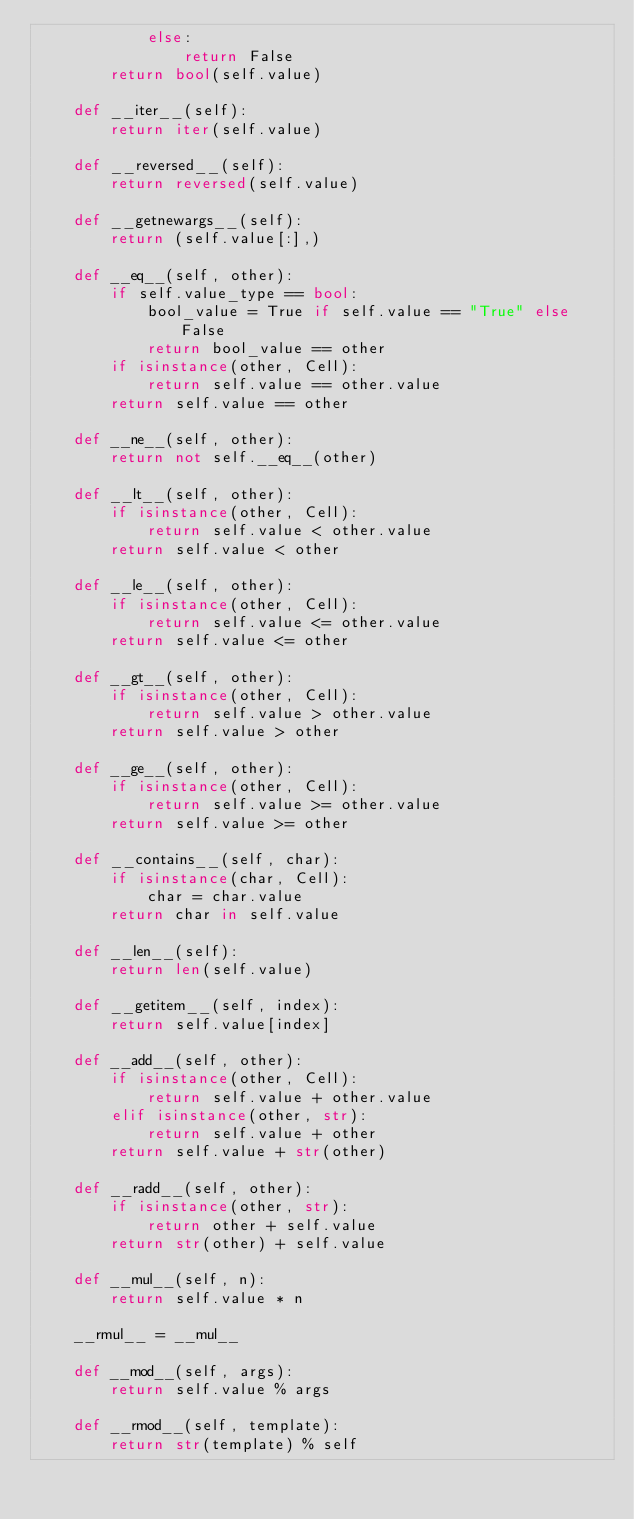<code> <loc_0><loc_0><loc_500><loc_500><_Python_>            else:
                return False
        return bool(self.value)

    def __iter__(self):
        return iter(self.value)

    def __reversed__(self):
        return reversed(self.value)

    def __getnewargs__(self):
        return (self.value[:],)

    def __eq__(self, other):
        if self.value_type == bool:
            bool_value = True if self.value == "True" else False
            return bool_value == other
        if isinstance(other, Cell):
            return self.value == other.value
        return self.value == other

    def __ne__(self, other):
        return not self.__eq__(other)

    def __lt__(self, other):
        if isinstance(other, Cell):
            return self.value < other.value
        return self.value < other

    def __le__(self, other):
        if isinstance(other, Cell):
            return self.value <= other.value
        return self.value <= other

    def __gt__(self, other):
        if isinstance(other, Cell):
            return self.value > other.value
        return self.value > other

    def __ge__(self, other):
        if isinstance(other, Cell):
            return self.value >= other.value
        return self.value >= other

    def __contains__(self, char):
        if isinstance(char, Cell):
            char = char.value
        return char in self.value

    def __len__(self):
        return len(self.value)

    def __getitem__(self, index):
        return self.value[index]

    def __add__(self, other):
        if isinstance(other, Cell):
            return self.value + other.value
        elif isinstance(other, str):
            return self.value + other
        return self.value + str(other)

    def __radd__(self, other):
        if isinstance(other, str):
            return other + self.value
        return str(other) + self.value

    def __mul__(self, n):
        return self.value * n

    __rmul__ = __mul__

    def __mod__(self, args):
        return self.value % args

    def __rmod__(self, template):
        return str(template) % self
</code> 